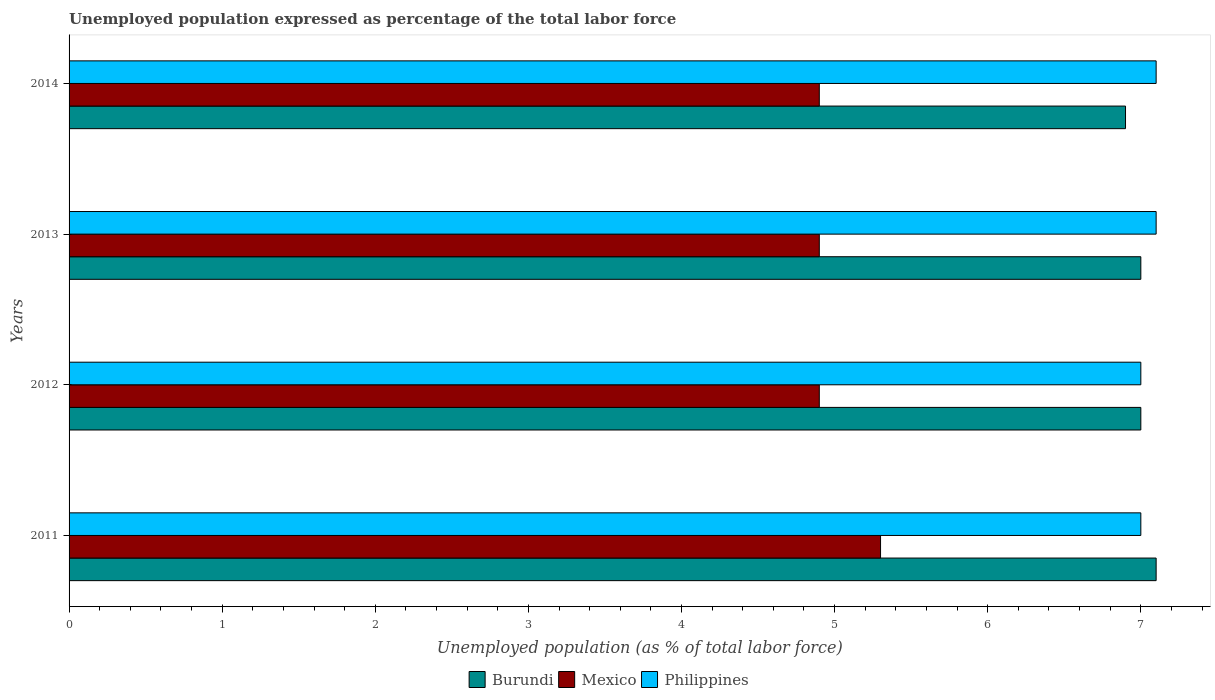Are the number of bars per tick equal to the number of legend labels?
Your response must be concise. Yes. Are the number of bars on each tick of the Y-axis equal?
Offer a very short reply. Yes. How many bars are there on the 4th tick from the top?
Keep it short and to the point. 3. How many bars are there on the 1st tick from the bottom?
Ensure brevity in your answer.  3. What is the unemployment in in Burundi in 2014?
Offer a very short reply. 6.9. Across all years, what is the maximum unemployment in in Burundi?
Your answer should be compact. 7.1. Across all years, what is the minimum unemployment in in Mexico?
Your response must be concise. 4.9. In which year was the unemployment in in Burundi minimum?
Ensure brevity in your answer.  2014. What is the total unemployment in in Philippines in the graph?
Provide a succinct answer. 28.2. What is the difference between the unemployment in in Burundi in 2012 and that in 2013?
Make the answer very short. 0. What is the difference between the unemployment in in Burundi in 2014 and the unemployment in in Philippines in 2013?
Keep it short and to the point. -0.2. What is the average unemployment in in Mexico per year?
Your answer should be compact. 5. In the year 2013, what is the difference between the unemployment in in Mexico and unemployment in in Philippines?
Your response must be concise. -2.2. In how many years, is the unemployment in in Burundi greater than 3.4 %?
Your response must be concise. 4. What is the ratio of the unemployment in in Mexico in 2011 to that in 2014?
Provide a succinct answer. 1.08. What is the difference between the highest and the lowest unemployment in in Philippines?
Make the answer very short. 0.1. Is the sum of the unemployment in in Mexico in 2012 and 2014 greater than the maximum unemployment in in Philippines across all years?
Provide a short and direct response. Yes. What does the 2nd bar from the top in 2014 represents?
Provide a short and direct response. Mexico. What does the 2nd bar from the bottom in 2013 represents?
Offer a terse response. Mexico. Is it the case that in every year, the sum of the unemployment in in Philippines and unemployment in in Mexico is greater than the unemployment in in Burundi?
Your response must be concise. Yes. How many years are there in the graph?
Offer a very short reply. 4. What is the difference between two consecutive major ticks on the X-axis?
Offer a terse response. 1. Are the values on the major ticks of X-axis written in scientific E-notation?
Keep it short and to the point. No. Does the graph contain grids?
Give a very brief answer. No. What is the title of the graph?
Give a very brief answer. Unemployed population expressed as percentage of the total labor force. Does "San Marino" appear as one of the legend labels in the graph?
Your answer should be compact. No. What is the label or title of the X-axis?
Provide a short and direct response. Unemployed population (as % of total labor force). What is the Unemployed population (as % of total labor force) in Burundi in 2011?
Your answer should be compact. 7.1. What is the Unemployed population (as % of total labor force) in Mexico in 2011?
Your answer should be compact. 5.3. What is the Unemployed population (as % of total labor force) of Philippines in 2011?
Give a very brief answer. 7. What is the Unemployed population (as % of total labor force) of Burundi in 2012?
Offer a very short reply. 7. What is the Unemployed population (as % of total labor force) of Mexico in 2012?
Ensure brevity in your answer.  4.9. What is the Unemployed population (as % of total labor force) of Burundi in 2013?
Provide a short and direct response. 7. What is the Unemployed population (as % of total labor force) in Mexico in 2013?
Give a very brief answer. 4.9. What is the Unemployed population (as % of total labor force) in Philippines in 2013?
Your answer should be very brief. 7.1. What is the Unemployed population (as % of total labor force) in Burundi in 2014?
Your response must be concise. 6.9. What is the Unemployed population (as % of total labor force) of Mexico in 2014?
Ensure brevity in your answer.  4.9. What is the Unemployed population (as % of total labor force) of Philippines in 2014?
Offer a very short reply. 7.1. Across all years, what is the maximum Unemployed population (as % of total labor force) in Burundi?
Your answer should be compact. 7.1. Across all years, what is the maximum Unemployed population (as % of total labor force) of Mexico?
Give a very brief answer. 5.3. Across all years, what is the maximum Unemployed population (as % of total labor force) in Philippines?
Ensure brevity in your answer.  7.1. Across all years, what is the minimum Unemployed population (as % of total labor force) in Burundi?
Your response must be concise. 6.9. Across all years, what is the minimum Unemployed population (as % of total labor force) in Mexico?
Ensure brevity in your answer.  4.9. What is the total Unemployed population (as % of total labor force) in Philippines in the graph?
Keep it short and to the point. 28.2. What is the difference between the Unemployed population (as % of total labor force) of Philippines in 2011 and that in 2012?
Your answer should be very brief. 0. What is the difference between the Unemployed population (as % of total labor force) of Burundi in 2011 and that in 2013?
Offer a terse response. 0.1. What is the difference between the Unemployed population (as % of total labor force) of Burundi in 2011 and that in 2014?
Your answer should be very brief. 0.2. What is the difference between the Unemployed population (as % of total labor force) of Philippines in 2011 and that in 2014?
Offer a terse response. -0.1. What is the difference between the Unemployed population (as % of total labor force) in Burundi in 2012 and that in 2013?
Ensure brevity in your answer.  0. What is the difference between the Unemployed population (as % of total labor force) of Mexico in 2012 and that in 2013?
Your answer should be very brief. 0. What is the difference between the Unemployed population (as % of total labor force) of Mexico in 2012 and that in 2014?
Provide a succinct answer. 0. What is the difference between the Unemployed population (as % of total labor force) of Burundi in 2013 and that in 2014?
Your answer should be very brief. 0.1. What is the difference between the Unemployed population (as % of total labor force) in Mexico in 2011 and the Unemployed population (as % of total labor force) in Philippines in 2012?
Offer a terse response. -1.7. What is the difference between the Unemployed population (as % of total labor force) in Burundi in 2011 and the Unemployed population (as % of total labor force) in Mexico in 2013?
Keep it short and to the point. 2.2. What is the difference between the Unemployed population (as % of total labor force) of Mexico in 2011 and the Unemployed population (as % of total labor force) of Philippines in 2013?
Your answer should be very brief. -1.8. What is the difference between the Unemployed population (as % of total labor force) of Burundi in 2011 and the Unemployed population (as % of total labor force) of Mexico in 2014?
Give a very brief answer. 2.2. What is the difference between the Unemployed population (as % of total labor force) of Burundi in 2012 and the Unemployed population (as % of total labor force) of Mexico in 2013?
Ensure brevity in your answer.  2.1. What is the difference between the Unemployed population (as % of total labor force) of Burundi in 2012 and the Unemployed population (as % of total labor force) of Mexico in 2014?
Your response must be concise. 2.1. What is the difference between the Unemployed population (as % of total labor force) of Burundi in 2012 and the Unemployed population (as % of total labor force) of Philippines in 2014?
Keep it short and to the point. -0.1. What is the difference between the Unemployed population (as % of total labor force) of Burundi in 2013 and the Unemployed population (as % of total labor force) of Mexico in 2014?
Your response must be concise. 2.1. What is the difference between the Unemployed population (as % of total labor force) of Mexico in 2013 and the Unemployed population (as % of total labor force) of Philippines in 2014?
Make the answer very short. -2.2. What is the average Unemployed population (as % of total labor force) of Burundi per year?
Your response must be concise. 7. What is the average Unemployed population (as % of total labor force) in Philippines per year?
Offer a very short reply. 7.05. In the year 2011, what is the difference between the Unemployed population (as % of total labor force) of Burundi and Unemployed population (as % of total labor force) of Mexico?
Your response must be concise. 1.8. In the year 2011, what is the difference between the Unemployed population (as % of total labor force) in Mexico and Unemployed population (as % of total labor force) in Philippines?
Offer a very short reply. -1.7. In the year 2013, what is the difference between the Unemployed population (as % of total labor force) of Mexico and Unemployed population (as % of total labor force) of Philippines?
Keep it short and to the point. -2.2. In the year 2014, what is the difference between the Unemployed population (as % of total labor force) of Burundi and Unemployed population (as % of total labor force) of Mexico?
Your response must be concise. 2. In the year 2014, what is the difference between the Unemployed population (as % of total labor force) of Burundi and Unemployed population (as % of total labor force) of Philippines?
Give a very brief answer. -0.2. What is the ratio of the Unemployed population (as % of total labor force) in Burundi in 2011 to that in 2012?
Give a very brief answer. 1.01. What is the ratio of the Unemployed population (as % of total labor force) of Mexico in 2011 to that in 2012?
Make the answer very short. 1.08. What is the ratio of the Unemployed population (as % of total labor force) in Burundi in 2011 to that in 2013?
Your answer should be compact. 1.01. What is the ratio of the Unemployed population (as % of total labor force) in Mexico in 2011 to that in 2013?
Your answer should be compact. 1.08. What is the ratio of the Unemployed population (as % of total labor force) in Philippines in 2011 to that in 2013?
Offer a terse response. 0.99. What is the ratio of the Unemployed population (as % of total labor force) of Burundi in 2011 to that in 2014?
Provide a short and direct response. 1.03. What is the ratio of the Unemployed population (as % of total labor force) in Mexico in 2011 to that in 2014?
Offer a very short reply. 1.08. What is the ratio of the Unemployed population (as % of total labor force) of Philippines in 2011 to that in 2014?
Make the answer very short. 0.99. What is the ratio of the Unemployed population (as % of total labor force) in Mexico in 2012 to that in 2013?
Provide a short and direct response. 1. What is the ratio of the Unemployed population (as % of total labor force) in Philippines in 2012 to that in 2013?
Your response must be concise. 0.99. What is the ratio of the Unemployed population (as % of total labor force) of Burundi in 2012 to that in 2014?
Your answer should be compact. 1.01. What is the ratio of the Unemployed population (as % of total labor force) in Philippines in 2012 to that in 2014?
Give a very brief answer. 0.99. What is the ratio of the Unemployed population (as % of total labor force) in Burundi in 2013 to that in 2014?
Your answer should be compact. 1.01. What is the difference between the highest and the second highest Unemployed population (as % of total labor force) in Burundi?
Offer a terse response. 0.1. What is the difference between the highest and the lowest Unemployed population (as % of total labor force) of Philippines?
Your answer should be very brief. 0.1. 